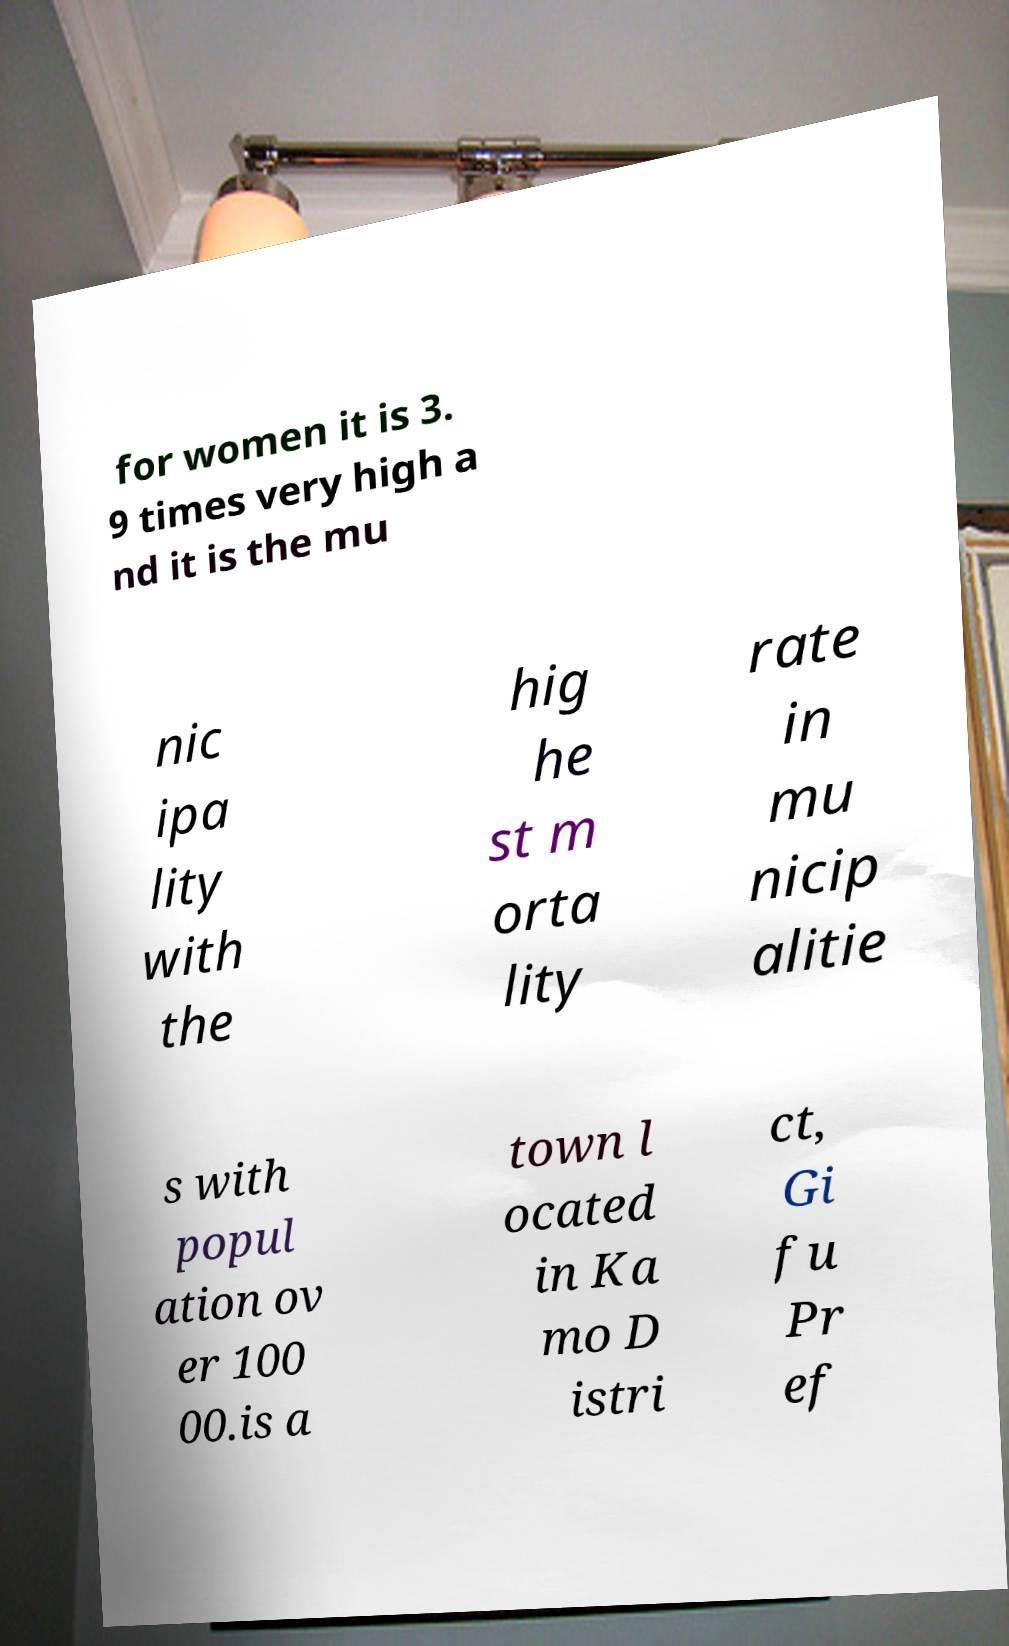Can you read and provide the text displayed in the image?This photo seems to have some interesting text. Can you extract and type it out for me? for women it is 3. 9 times very high a nd it is the mu nic ipa lity with the hig he st m orta lity rate in mu nicip alitie s with popul ation ov er 100 00.is a town l ocated in Ka mo D istri ct, Gi fu Pr ef 